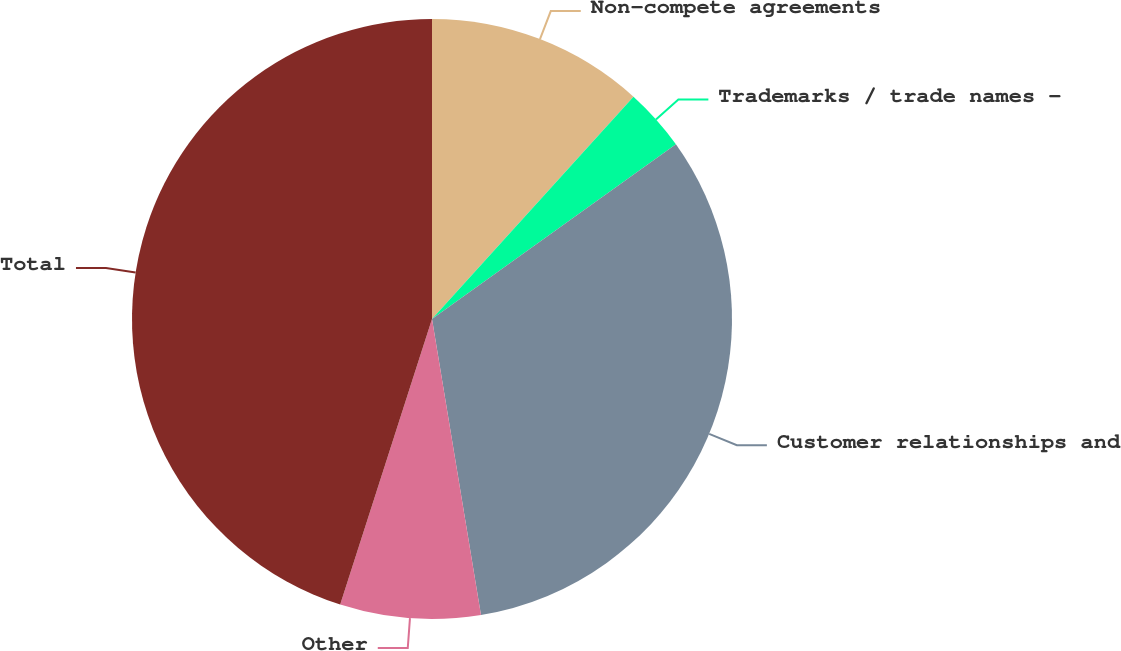<chart> <loc_0><loc_0><loc_500><loc_500><pie_chart><fcel>Non-compete agreements<fcel>Trademarks / trade names -<fcel>Customer relationships and<fcel>Other<fcel>Total<nl><fcel>11.72%<fcel>3.39%<fcel>32.28%<fcel>7.56%<fcel>45.05%<nl></chart> 